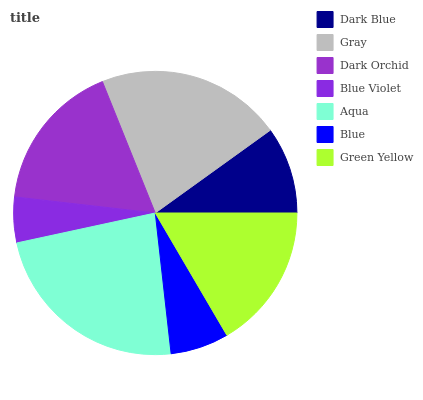Is Blue Violet the minimum?
Answer yes or no. Yes. Is Aqua the maximum?
Answer yes or no. Yes. Is Gray the minimum?
Answer yes or no. No. Is Gray the maximum?
Answer yes or no. No. Is Gray greater than Dark Blue?
Answer yes or no. Yes. Is Dark Blue less than Gray?
Answer yes or no. Yes. Is Dark Blue greater than Gray?
Answer yes or no. No. Is Gray less than Dark Blue?
Answer yes or no. No. Is Green Yellow the high median?
Answer yes or no. Yes. Is Green Yellow the low median?
Answer yes or no. Yes. Is Blue the high median?
Answer yes or no. No. Is Dark Orchid the low median?
Answer yes or no. No. 